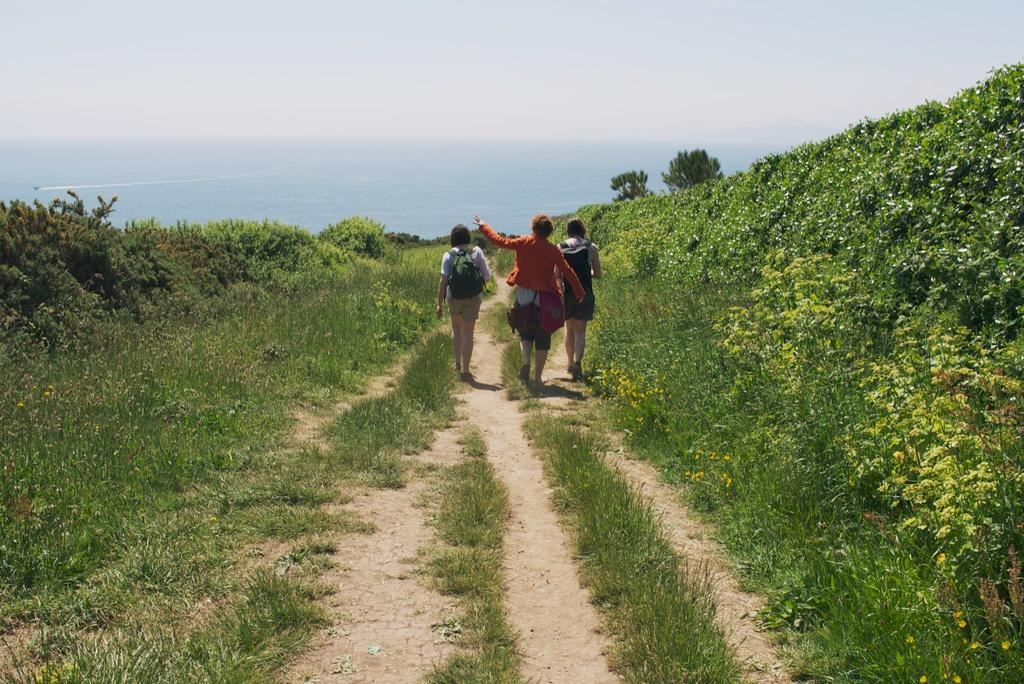How many people can be seen walking in the image? There are three people walking in the image. What else can be seen in the image besides the people? There are three plants or trees in the image. What type of toothpaste is being used by the people in the image? There is no toothpaste present in the image; it features three people walking and three plants or trees. Can you describe the facial expressions of the people in the image? The provided facts do not mention any facial expressions of the people in the image. 